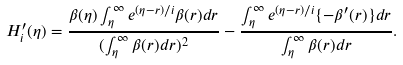<formula> <loc_0><loc_0><loc_500><loc_500>H ^ { \prime } _ { i } ( \eta ) = \frac { \beta ( \eta ) \int _ { \eta } ^ { \infty } e ^ { ( \eta - r ) / i } \beta ( r ) d r } { ( \int _ { \eta } ^ { \infty } \beta ( r ) d r ) ^ { 2 } } - \frac { \int _ { \eta } ^ { \infty } e ^ { ( \eta - r ) / i } \{ - \beta ^ { \prime } ( r ) \} d r } { \int _ { \eta } ^ { \infty } \beta ( r ) d r } .</formula> 